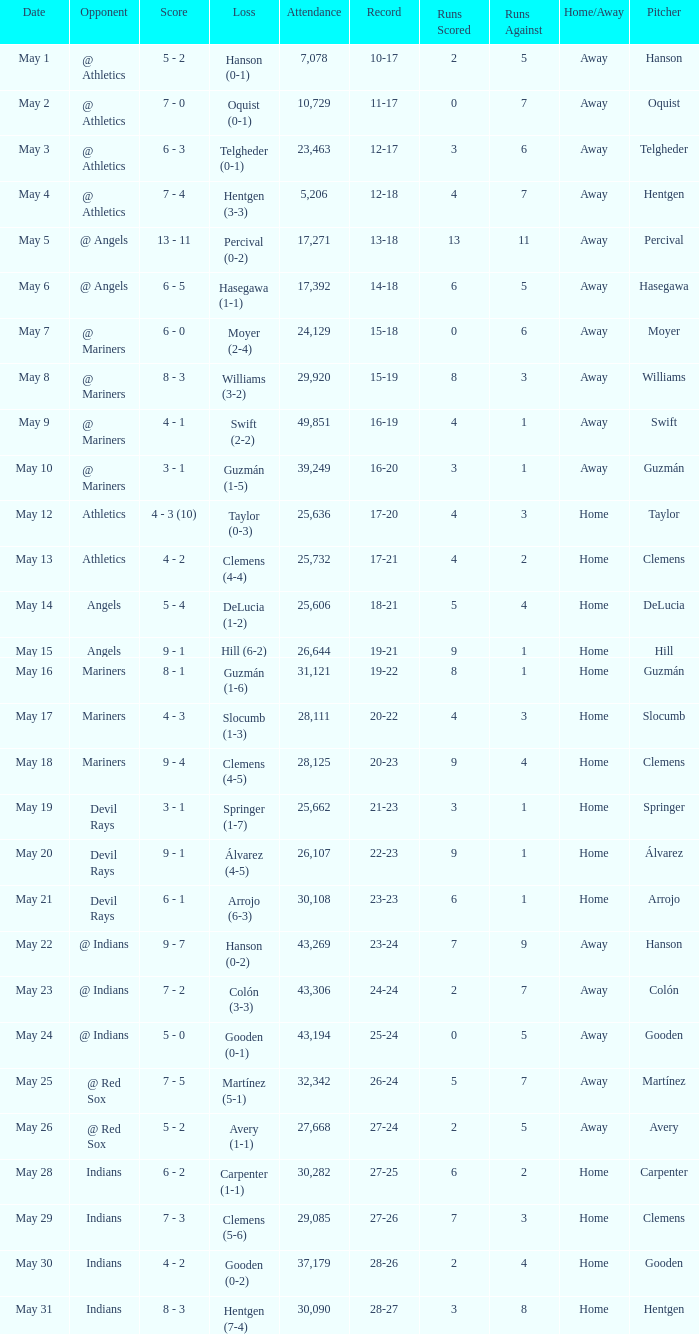When was the record 27-25? May 28. 